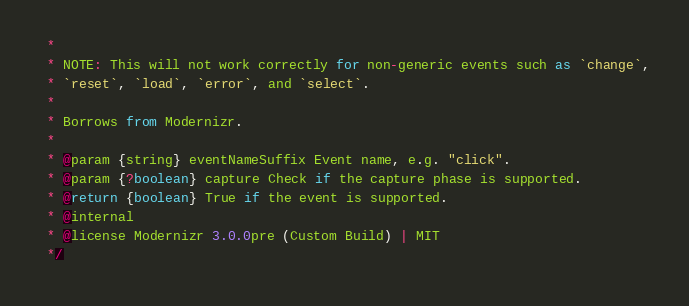<code> <loc_0><loc_0><loc_500><loc_500><_JavaScript_> *
 * NOTE: This will not work correctly for non-generic events such as `change`,
 * `reset`, `load`, `error`, and `select`.
 *
 * Borrows from Modernizr.
 *
 * @param {string} eventNameSuffix Event name, e.g. "click".
 * @param {?boolean} capture Check if the capture phase is supported.
 * @return {boolean} True if the event is supported.
 * @internal
 * @license Modernizr 3.0.0pre (Custom Build) | MIT
 */</code> 